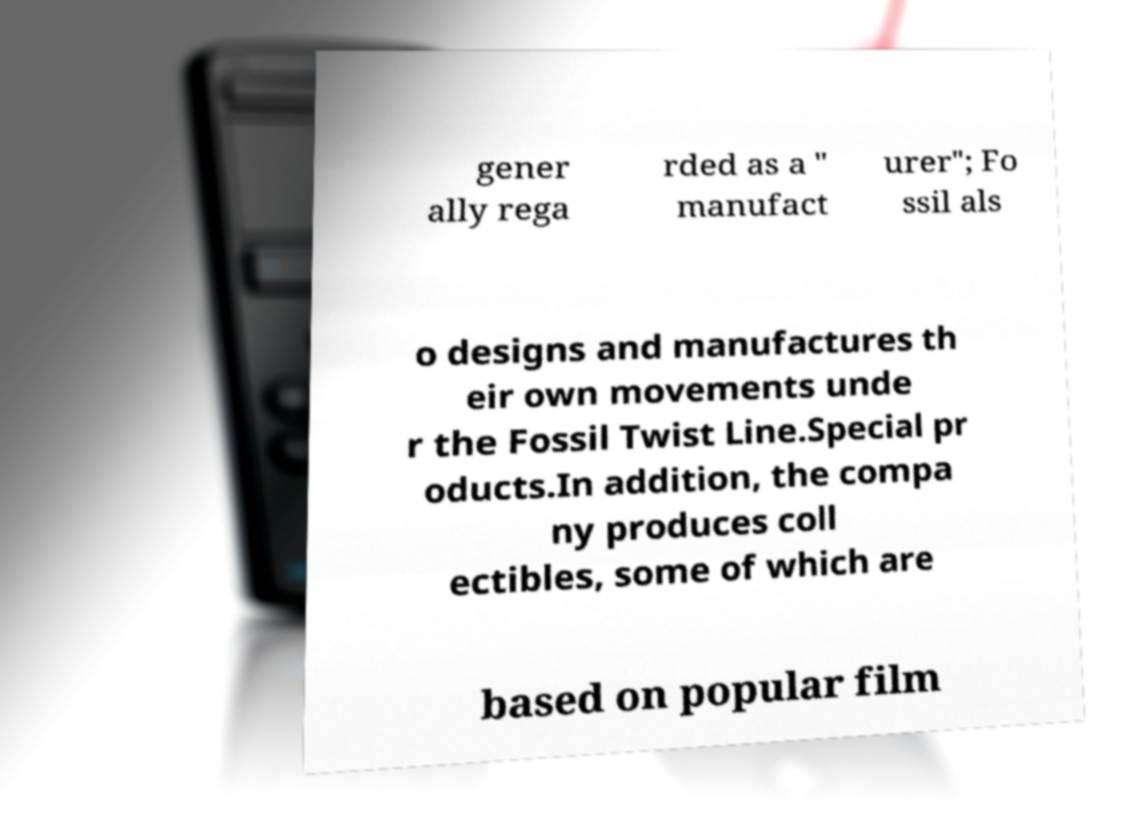For documentation purposes, I need the text within this image transcribed. Could you provide that? gener ally rega rded as a " manufact urer"; Fo ssil als o designs and manufactures th eir own movements unde r the Fossil Twist Line.Special pr oducts.In addition, the compa ny produces coll ectibles, some of which are based on popular film 